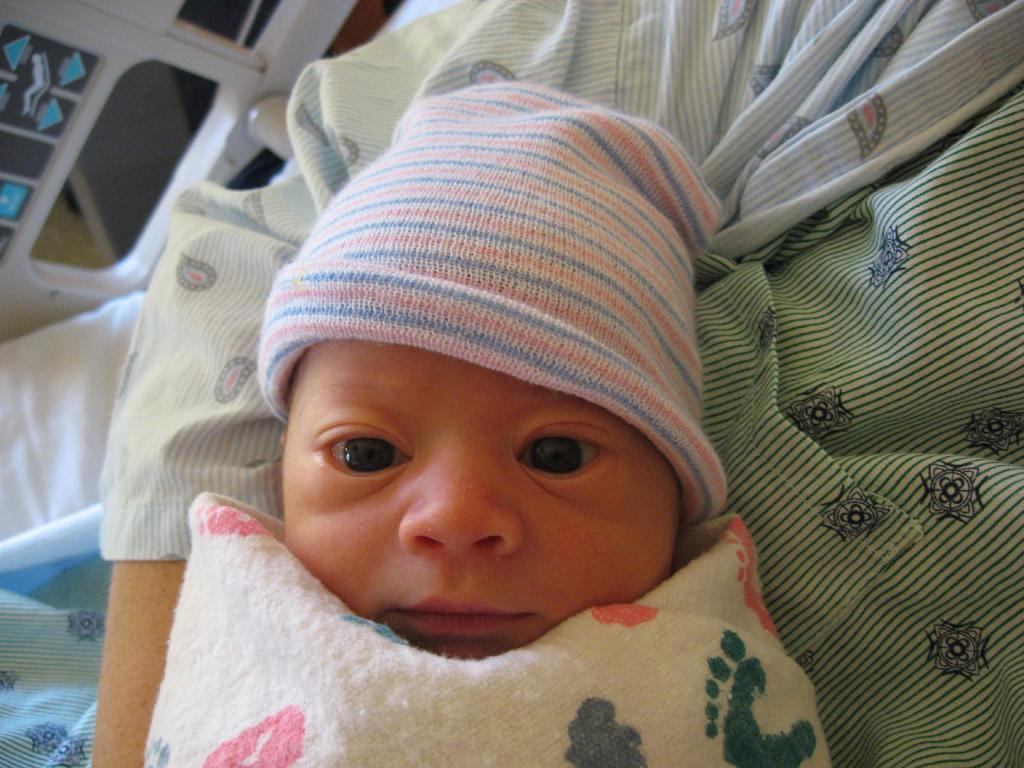How would you summarize this image in a sentence or two? In the picture I can see a person is carrying a child. The child is wearing a cap and covered with clothes. In the background I can see some objects. 